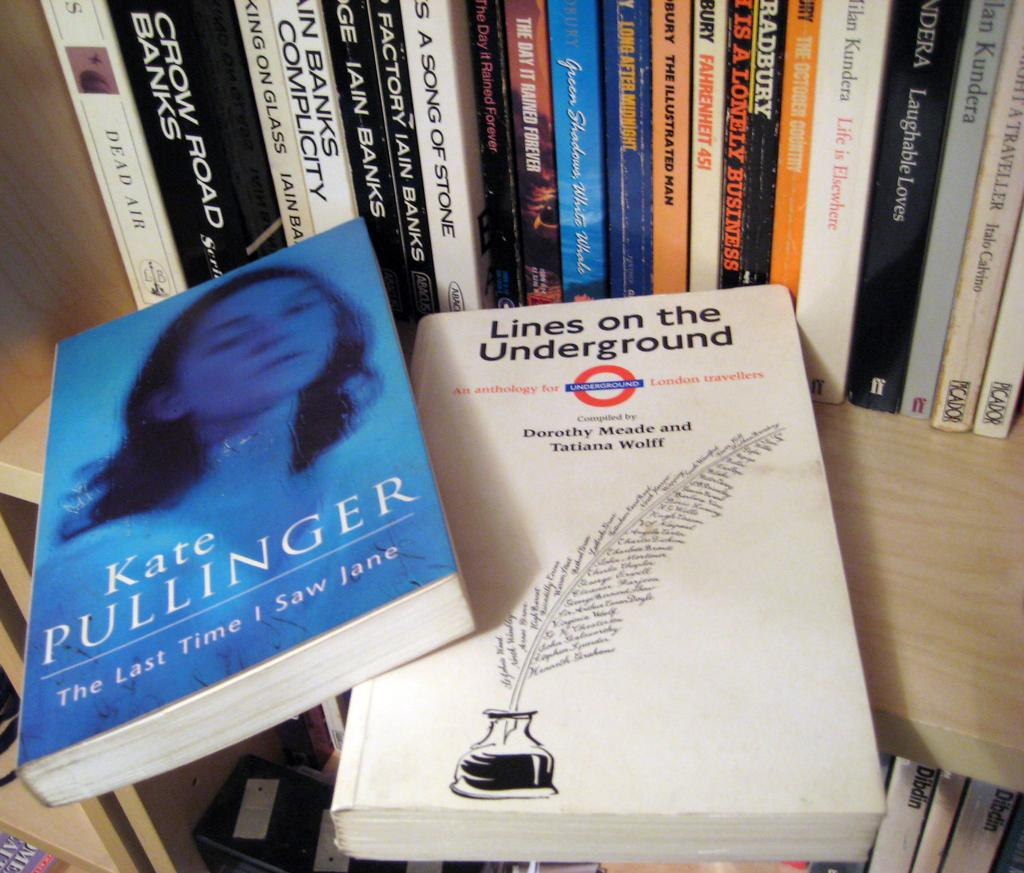<image>
Provide a brief description of the given image. Several books on a shelf stand behind The Last Time I Saw Jane by Kate Pullinger and Lines on the Underground compiled by Dorothy Meade and Tatiana Wolff. 